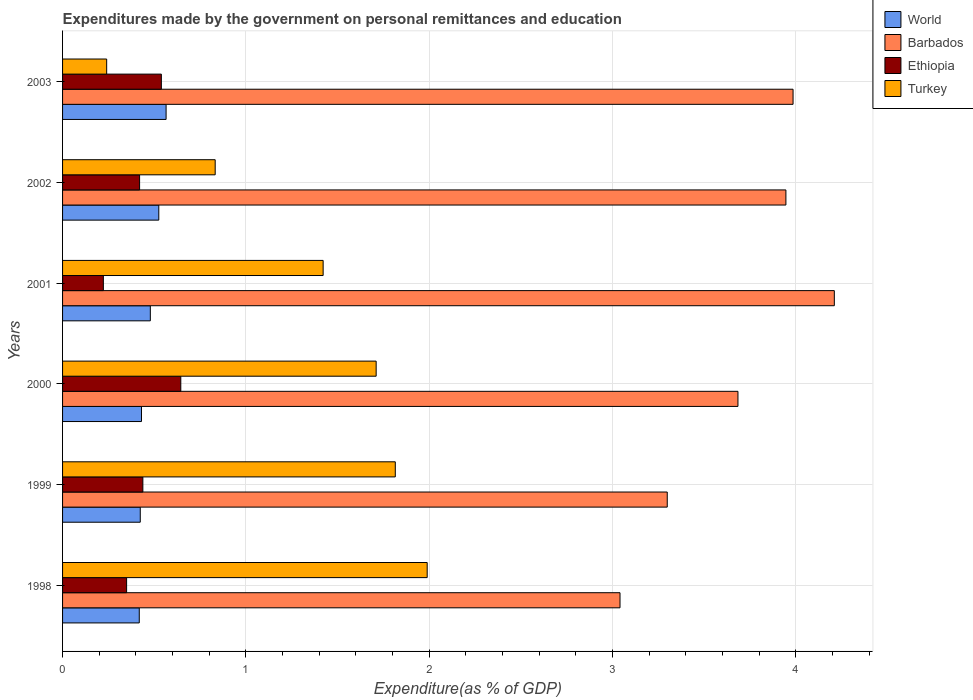How many groups of bars are there?
Your answer should be compact. 6. Are the number of bars per tick equal to the number of legend labels?
Make the answer very short. Yes. How many bars are there on the 4th tick from the top?
Your answer should be compact. 4. How many bars are there on the 6th tick from the bottom?
Your answer should be very brief. 4. What is the label of the 6th group of bars from the top?
Provide a succinct answer. 1998. In how many cases, is the number of bars for a given year not equal to the number of legend labels?
Ensure brevity in your answer.  0. What is the expenditures made by the government on personal remittances and education in World in 2003?
Make the answer very short. 0.56. Across all years, what is the maximum expenditures made by the government on personal remittances and education in Ethiopia?
Give a very brief answer. 0.64. Across all years, what is the minimum expenditures made by the government on personal remittances and education in Turkey?
Provide a succinct answer. 0.24. In which year was the expenditures made by the government on personal remittances and education in World maximum?
Keep it short and to the point. 2003. What is the total expenditures made by the government on personal remittances and education in Turkey in the graph?
Your answer should be very brief. 8.01. What is the difference between the expenditures made by the government on personal remittances and education in Turkey in 1998 and that in 2001?
Ensure brevity in your answer.  0.57. What is the difference between the expenditures made by the government on personal remittances and education in Ethiopia in 1999 and the expenditures made by the government on personal remittances and education in Turkey in 2002?
Provide a short and direct response. -0.39. What is the average expenditures made by the government on personal remittances and education in Ethiopia per year?
Provide a succinct answer. 0.44. In the year 1998, what is the difference between the expenditures made by the government on personal remittances and education in Ethiopia and expenditures made by the government on personal remittances and education in World?
Provide a short and direct response. -0.07. In how many years, is the expenditures made by the government on personal remittances and education in Turkey greater than 1.4 %?
Your answer should be compact. 4. What is the ratio of the expenditures made by the government on personal remittances and education in World in 1998 to that in 1999?
Provide a succinct answer. 0.99. Is the expenditures made by the government on personal remittances and education in Turkey in 2000 less than that in 2001?
Give a very brief answer. No. Is the difference between the expenditures made by the government on personal remittances and education in Ethiopia in 1999 and 2001 greater than the difference between the expenditures made by the government on personal remittances and education in World in 1999 and 2001?
Offer a very short reply. Yes. What is the difference between the highest and the second highest expenditures made by the government on personal remittances and education in Ethiopia?
Give a very brief answer. 0.11. What is the difference between the highest and the lowest expenditures made by the government on personal remittances and education in Ethiopia?
Offer a terse response. 0.42. What does the 2nd bar from the top in 1999 represents?
Give a very brief answer. Ethiopia. What does the 1st bar from the bottom in 2003 represents?
Your response must be concise. World. How many bars are there?
Make the answer very short. 24. How many years are there in the graph?
Provide a short and direct response. 6. Are the values on the major ticks of X-axis written in scientific E-notation?
Provide a succinct answer. No. Does the graph contain any zero values?
Provide a succinct answer. No. Where does the legend appear in the graph?
Make the answer very short. Top right. How many legend labels are there?
Ensure brevity in your answer.  4. What is the title of the graph?
Make the answer very short. Expenditures made by the government on personal remittances and education. What is the label or title of the X-axis?
Ensure brevity in your answer.  Expenditure(as % of GDP). What is the Expenditure(as % of GDP) in World in 1998?
Make the answer very short. 0.42. What is the Expenditure(as % of GDP) in Barbados in 1998?
Your answer should be very brief. 3.04. What is the Expenditure(as % of GDP) in Ethiopia in 1998?
Your answer should be very brief. 0.35. What is the Expenditure(as % of GDP) of Turkey in 1998?
Keep it short and to the point. 1.99. What is the Expenditure(as % of GDP) in World in 1999?
Offer a very short reply. 0.42. What is the Expenditure(as % of GDP) in Barbados in 1999?
Make the answer very short. 3.3. What is the Expenditure(as % of GDP) in Ethiopia in 1999?
Your answer should be compact. 0.44. What is the Expenditure(as % of GDP) of Turkey in 1999?
Ensure brevity in your answer.  1.82. What is the Expenditure(as % of GDP) in World in 2000?
Provide a short and direct response. 0.43. What is the Expenditure(as % of GDP) of Barbados in 2000?
Offer a terse response. 3.68. What is the Expenditure(as % of GDP) in Ethiopia in 2000?
Your response must be concise. 0.64. What is the Expenditure(as % of GDP) in Turkey in 2000?
Provide a succinct answer. 1.71. What is the Expenditure(as % of GDP) of World in 2001?
Your answer should be compact. 0.48. What is the Expenditure(as % of GDP) in Barbados in 2001?
Offer a very short reply. 4.21. What is the Expenditure(as % of GDP) of Ethiopia in 2001?
Your response must be concise. 0.22. What is the Expenditure(as % of GDP) of Turkey in 2001?
Your response must be concise. 1.42. What is the Expenditure(as % of GDP) in World in 2002?
Ensure brevity in your answer.  0.52. What is the Expenditure(as % of GDP) of Barbados in 2002?
Offer a terse response. 3.95. What is the Expenditure(as % of GDP) in Ethiopia in 2002?
Provide a succinct answer. 0.42. What is the Expenditure(as % of GDP) in Turkey in 2002?
Keep it short and to the point. 0.83. What is the Expenditure(as % of GDP) in World in 2003?
Offer a terse response. 0.56. What is the Expenditure(as % of GDP) of Barbados in 2003?
Give a very brief answer. 3.98. What is the Expenditure(as % of GDP) of Ethiopia in 2003?
Your answer should be compact. 0.54. What is the Expenditure(as % of GDP) of Turkey in 2003?
Your answer should be compact. 0.24. Across all years, what is the maximum Expenditure(as % of GDP) in World?
Offer a very short reply. 0.56. Across all years, what is the maximum Expenditure(as % of GDP) of Barbados?
Provide a succinct answer. 4.21. Across all years, what is the maximum Expenditure(as % of GDP) of Ethiopia?
Offer a terse response. 0.64. Across all years, what is the maximum Expenditure(as % of GDP) in Turkey?
Make the answer very short. 1.99. Across all years, what is the minimum Expenditure(as % of GDP) in World?
Provide a short and direct response. 0.42. Across all years, what is the minimum Expenditure(as % of GDP) of Barbados?
Offer a terse response. 3.04. Across all years, what is the minimum Expenditure(as % of GDP) of Ethiopia?
Your response must be concise. 0.22. Across all years, what is the minimum Expenditure(as % of GDP) of Turkey?
Offer a very short reply. 0.24. What is the total Expenditure(as % of GDP) in World in the graph?
Your answer should be compact. 2.84. What is the total Expenditure(as % of GDP) in Barbados in the graph?
Offer a terse response. 22.16. What is the total Expenditure(as % of GDP) of Ethiopia in the graph?
Make the answer very short. 2.61. What is the total Expenditure(as % of GDP) in Turkey in the graph?
Provide a short and direct response. 8.01. What is the difference between the Expenditure(as % of GDP) in World in 1998 and that in 1999?
Keep it short and to the point. -0.01. What is the difference between the Expenditure(as % of GDP) in Barbados in 1998 and that in 1999?
Provide a short and direct response. -0.26. What is the difference between the Expenditure(as % of GDP) of Ethiopia in 1998 and that in 1999?
Make the answer very short. -0.09. What is the difference between the Expenditure(as % of GDP) in Turkey in 1998 and that in 1999?
Keep it short and to the point. 0.17. What is the difference between the Expenditure(as % of GDP) of World in 1998 and that in 2000?
Provide a succinct answer. -0.01. What is the difference between the Expenditure(as % of GDP) in Barbados in 1998 and that in 2000?
Offer a very short reply. -0.64. What is the difference between the Expenditure(as % of GDP) in Ethiopia in 1998 and that in 2000?
Ensure brevity in your answer.  -0.3. What is the difference between the Expenditure(as % of GDP) in Turkey in 1998 and that in 2000?
Offer a very short reply. 0.28. What is the difference between the Expenditure(as % of GDP) in World in 1998 and that in 2001?
Make the answer very short. -0.06. What is the difference between the Expenditure(as % of GDP) in Barbados in 1998 and that in 2001?
Provide a short and direct response. -1.17. What is the difference between the Expenditure(as % of GDP) of Ethiopia in 1998 and that in 2001?
Ensure brevity in your answer.  0.13. What is the difference between the Expenditure(as % of GDP) of Turkey in 1998 and that in 2001?
Provide a succinct answer. 0.57. What is the difference between the Expenditure(as % of GDP) of World in 1998 and that in 2002?
Provide a succinct answer. -0.11. What is the difference between the Expenditure(as % of GDP) of Barbados in 1998 and that in 2002?
Offer a very short reply. -0.91. What is the difference between the Expenditure(as % of GDP) in Ethiopia in 1998 and that in 2002?
Offer a terse response. -0.07. What is the difference between the Expenditure(as % of GDP) of Turkey in 1998 and that in 2002?
Your answer should be compact. 1.16. What is the difference between the Expenditure(as % of GDP) in World in 1998 and that in 2003?
Provide a succinct answer. -0.15. What is the difference between the Expenditure(as % of GDP) of Barbados in 1998 and that in 2003?
Provide a short and direct response. -0.94. What is the difference between the Expenditure(as % of GDP) in Ethiopia in 1998 and that in 2003?
Ensure brevity in your answer.  -0.19. What is the difference between the Expenditure(as % of GDP) of Turkey in 1998 and that in 2003?
Make the answer very short. 1.75. What is the difference between the Expenditure(as % of GDP) of World in 1999 and that in 2000?
Keep it short and to the point. -0.01. What is the difference between the Expenditure(as % of GDP) in Barbados in 1999 and that in 2000?
Your response must be concise. -0.39. What is the difference between the Expenditure(as % of GDP) in Ethiopia in 1999 and that in 2000?
Your answer should be compact. -0.21. What is the difference between the Expenditure(as % of GDP) of Turkey in 1999 and that in 2000?
Your answer should be very brief. 0.1. What is the difference between the Expenditure(as % of GDP) in World in 1999 and that in 2001?
Your answer should be very brief. -0.05. What is the difference between the Expenditure(as % of GDP) in Barbados in 1999 and that in 2001?
Keep it short and to the point. -0.91. What is the difference between the Expenditure(as % of GDP) of Ethiopia in 1999 and that in 2001?
Make the answer very short. 0.22. What is the difference between the Expenditure(as % of GDP) in Turkey in 1999 and that in 2001?
Your response must be concise. 0.39. What is the difference between the Expenditure(as % of GDP) of World in 1999 and that in 2002?
Provide a succinct answer. -0.1. What is the difference between the Expenditure(as % of GDP) of Barbados in 1999 and that in 2002?
Your answer should be compact. -0.65. What is the difference between the Expenditure(as % of GDP) of Ethiopia in 1999 and that in 2002?
Give a very brief answer. 0.02. What is the difference between the Expenditure(as % of GDP) of Turkey in 1999 and that in 2002?
Offer a very short reply. 0.98. What is the difference between the Expenditure(as % of GDP) in World in 1999 and that in 2003?
Provide a succinct answer. -0.14. What is the difference between the Expenditure(as % of GDP) in Barbados in 1999 and that in 2003?
Provide a succinct answer. -0.69. What is the difference between the Expenditure(as % of GDP) of Ethiopia in 1999 and that in 2003?
Give a very brief answer. -0.1. What is the difference between the Expenditure(as % of GDP) of Turkey in 1999 and that in 2003?
Your answer should be very brief. 1.57. What is the difference between the Expenditure(as % of GDP) of World in 2000 and that in 2001?
Your response must be concise. -0.05. What is the difference between the Expenditure(as % of GDP) of Barbados in 2000 and that in 2001?
Give a very brief answer. -0.53. What is the difference between the Expenditure(as % of GDP) in Ethiopia in 2000 and that in 2001?
Offer a terse response. 0.42. What is the difference between the Expenditure(as % of GDP) in Turkey in 2000 and that in 2001?
Your response must be concise. 0.29. What is the difference between the Expenditure(as % of GDP) in World in 2000 and that in 2002?
Offer a terse response. -0.09. What is the difference between the Expenditure(as % of GDP) in Barbados in 2000 and that in 2002?
Provide a succinct answer. -0.26. What is the difference between the Expenditure(as % of GDP) in Ethiopia in 2000 and that in 2002?
Your answer should be very brief. 0.22. What is the difference between the Expenditure(as % of GDP) of Turkey in 2000 and that in 2002?
Your answer should be very brief. 0.88. What is the difference between the Expenditure(as % of GDP) of World in 2000 and that in 2003?
Your answer should be very brief. -0.13. What is the difference between the Expenditure(as % of GDP) of Barbados in 2000 and that in 2003?
Keep it short and to the point. -0.3. What is the difference between the Expenditure(as % of GDP) in Ethiopia in 2000 and that in 2003?
Your response must be concise. 0.11. What is the difference between the Expenditure(as % of GDP) in Turkey in 2000 and that in 2003?
Offer a terse response. 1.47. What is the difference between the Expenditure(as % of GDP) of World in 2001 and that in 2002?
Your answer should be compact. -0.05. What is the difference between the Expenditure(as % of GDP) of Barbados in 2001 and that in 2002?
Offer a very short reply. 0.26. What is the difference between the Expenditure(as % of GDP) in Ethiopia in 2001 and that in 2002?
Give a very brief answer. -0.2. What is the difference between the Expenditure(as % of GDP) in Turkey in 2001 and that in 2002?
Ensure brevity in your answer.  0.59. What is the difference between the Expenditure(as % of GDP) in World in 2001 and that in 2003?
Make the answer very short. -0.09. What is the difference between the Expenditure(as % of GDP) of Barbados in 2001 and that in 2003?
Your answer should be very brief. 0.23. What is the difference between the Expenditure(as % of GDP) in Ethiopia in 2001 and that in 2003?
Offer a very short reply. -0.32. What is the difference between the Expenditure(as % of GDP) of Turkey in 2001 and that in 2003?
Ensure brevity in your answer.  1.18. What is the difference between the Expenditure(as % of GDP) of World in 2002 and that in 2003?
Provide a succinct answer. -0.04. What is the difference between the Expenditure(as % of GDP) of Barbados in 2002 and that in 2003?
Provide a short and direct response. -0.04. What is the difference between the Expenditure(as % of GDP) in Ethiopia in 2002 and that in 2003?
Ensure brevity in your answer.  -0.12. What is the difference between the Expenditure(as % of GDP) in Turkey in 2002 and that in 2003?
Your response must be concise. 0.59. What is the difference between the Expenditure(as % of GDP) in World in 1998 and the Expenditure(as % of GDP) in Barbados in 1999?
Provide a succinct answer. -2.88. What is the difference between the Expenditure(as % of GDP) of World in 1998 and the Expenditure(as % of GDP) of Ethiopia in 1999?
Keep it short and to the point. -0.02. What is the difference between the Expenditure(as % of GDP) in World in 1998 and the Expenditure(as % of GDP) in Turkey in 1999?
Provide a short and direct response. -1.4. What is the difference between the Expenditure(as % of GDP) of Barbados in 1998 and the Expenditure(as % of GDP) of Ethiopia in 1999?
Provide a succinct answer. 2.6. What is the difference between the Expenditure(as % of GDP) of Barbados in 1998 and the Expenditure(as % of GDP) of Turkey in 1999?
Offer a terse response. 1.23. What is the difference between the Expenditure(as % of GDP) of Ethiopia in 1998 and the Expenditure(as % of GDP) of Turkey in 1999?
Keep it short and to the point. -1.47. What is the difference between the Expenditure(as % of GDP) in World in 1998 and the Expenditure(as % of GDP) in Barbados in 2000?
Your answer should be very brief. -3.27. What is the difference between the Expenditure(as % of GDP) in World in 1998 and the Expenditure(as % of GDP) in Ethiopia in 2000?
Your response must be concise. -0.23. What is the difference between the Expenditure(as % of GDP) in World in 1998 and the Expenditure(as % of GDP) in Turkey in 2000?
Make the answer very short. -1.29. What is the difference between the Expenditure(as % of GDP) of Barbados in 1998 and the Expenditure(as % of GDP) of Ethiopia in 2000?
Make the answer very short. 2.4. What is the difference between the Expenditure(as % of GDP) in Barbados in 1998 and the Expenditure(as % of GDP) in Turkey in 2000?
Ensure brevity in your answer.  1.33. What is the difference between the Expenditure(as % of GDP) of Ethiopia in 1998 and the Expenditure(as % of GDP) of Turkey in 2000?
Offer a terse response. -1.36. What is the difference between the Expenditure(as % of GDP) of World in 1998 and the Expenditure(as % of GDP) of Barbados in 2001?
Keep it short and to the point. -3.79. What is the difference between the Expenditure(as % of GDP) in World in 1998 and the Expenditure(as % of GDP) in Ethiopia in 2001?
Keep it short and to the point. 0.2. What is the difference between the Expenditure(as % of GDP) of World in 1998 and the Expenditure(as % of GDP) of Turkey in 2001?
Give a very brief answer. -1. What is the difference between the Expenditure(as % of GDP) in Barbados in 1998 and the Expenditure(as % of GDP) in Ethiopia in 2001?
Ensure brevity in your answer.  2.82. What is the difference between the Expenditure(as % of GDP) in Barbados in 1998 and the Expenditure(as % of GDP) in Turkey in 2001?
Your answer should be very brief. 1.62. What is the difference between the Expenditure(as % of GDP) in Ethiopia in 1998 and the Expenditure(as % of GDP) in Turkey in 2001?
Make the answer very short. -1.07. What is the difference between the Expenditure(as % of GDP) in World in 1998 and the Expenditure(as % of GDP) in Barbados in 2002?
Keep it short and to the point. -3.53. What is the difference between the Expenditure(as % of GDP) of World in 1998 and the Expenditure(as % of GDP) of Ethiopia in 2002?
Offer a terse response. -0. What is the difference between the Expenditure(as % of GDP) of World in 1998 and the Expenditure(as % of GDP) of Turkey in 2002?
Your response must be concise. -0.41. What is the difference between the Expenditure(as % of GDP) of Barbados in 1998 and the Expenditure(as % of GDP) of Ethiopia in 2002?
Your answer should be compact. 2.62. What is the difference between the Expenditure(as % of GDP) in Barbados in 1998 and the Expenditure(as % of GDP) in Turkey in 2002?
Give a very brief answer. 2.21. What is the difference between the Expenditure(as % of GDP) of Ethiopia in 1998 and the Expenditure(as % of GDP) of Turkey in 2002?
Offer a very short reply. -0.48. What is the difference between the Expenditure(as % of GDP) in World in 1998 and the Expenditure(as % of GDP) in Barbados in 2003?
Provide a short and direct response. -3.57. What is the difference between the Expenditure(as % of GDP) in World in 1998 and the Expenditure(as % of GDP) in Ethiopia in 2003?
Your response must be concise. -0.12. What is the difference between the Expenditure(as % of GDP) of World in 1998 and the Expenditure(as % of GDP) of Turkey in 2003?
Your answer should be compact. 0.18. What is the difference between the Expenditure(as % of GDP) in Barbados in 1998 and the Expenditure(as % of GDP) in Ethiopia in 2003?
Your answer should be compact. 2.5. What is the difference between the Expenditure(as % of GDP) in Barbados in 1998 and the Expenditure(as % of GDP) in Turkey in 2003?
Your answer should be compact. 2.8. What is the difference between the Expenditure(as % of GDP) of Ethiopia in 1998 and the Expenditure(as % of GDP) of Turkey in 2003?
Keep it short and to the point. 0.11. What is the difference between the Expenditure(as % of GDP) in World in 1999 and the Expenditure(as % of GDP) in Barbados in 2000?
Make the answer very short. -3.26. What is the difference between the Expenditure(as % of GDP) in World in 1999 and the Expenditure(as % of GDP) in Ethiopia in 2000?
Provide a short and direct response. -0.22. What is the difference between the Expenditure(as % of GDP) of World in 1999 and the Expenditure(as % of GDP) of Turkey in 2000?
Ensure brevity in your answer.  -1.29. What is the difference between the Expenditure(as % of GDP) of Barbados in 1999 and the Expenditure(as % of GDP) of Ethiopia in 2000?
Provide a short and direct response. 2.65. What is the difference between the Expenditure(as % of GDP) in Barbados in 1999 and the Expenditure(as % of GDP) in Turkey in 2000?
Ensure brevity in your answer.  1.59. What is the difference between the Expenditure(as % of GDP) of Ethiopia in 1999 and the Expenditure(as % of GDP) of Turkey in 2000?
Your response must be concise. -1.27. What is the difference between the Expenditure(as % of GDP) of World in 1999 and the Expenditure(as % of GDP) of Barbados in 2001?
Give a very brief answer. -3.79. What is the difference between the Expenditure(as % of GDP) in World in 1999 and the Expenditure(as % of GDP) in Ethiopia in 2001?
Offer a terse response. 0.2. What is the difference between the Expenditure(as % of GDP) in World in 1999 and the Expenditure(as % of GDP) in Turkey in 2001?
Provide a short and direct response. -1. What is the difference between the Expenditure(as % of GDP) of Barbados in 1999 and the Expenditure(as % of GDP) of Ethiopia in 2001?
Provide a succinct answer. 3.08. What is the difference between the Expenditure(as % of GDP) of Barbados in 1999 and the Expenditure(as % of GDP) of Turkey in 2001?
Ensure brevity in your answer.  1.88. What is the difference between the Expenditure(as % of GDP) of Ethiopia in 1999 and the Expenditure(as % of GDP) of Turkey in 2001?
Ensure brevity in your answer.  -0.98. What is the difference between the Expenditure(as % of GDP) in World in 1999 and the Expenditure(as % of GDP) in Barbados in 2002?
Offer a terse response. -3.52. What is the difference between the Expenditure(as % of GDP) in World in 1999 and the Expenditure(as % of GDP) in Ethiopia in 2002?
Keep it short and to the point. 0. What is the difference between the Expenditure(as % of GDP) in World in 1999 and the Expenditure(as % of GDP) in Turkey in 2002?
Provide a succinct answer. -0.41. What is the difference between the Expenditure(as % of GDP) in Barbados in 1999 and the Expenditure(as % of GDP) in Ethiopia in 2002?
Offer a very short reply. 2.88. What is the difference between the Expenditure(as % of GDP) of Barbados in 1999 and the Expenditure(as % of GDP) of Turkey in 2002?
Your response must be concise. 2.47. What is the difference between the Expenditure(as % of GDP) in Ethiopia in 1999 and the Expenditure(as % of GDP) in Turkey in 2002?
Offer a very short reply. -0.39. What is the difference between the Expenditure(as % of GDP) of World in 1999 and the Expenditure(as % of GDP) of Barbados in 2003?
Make the answer very short. -3.56. What is the difference between the Expenditure(as % of GDP) of World in 1999 and the Expenditure(as % of GDP) of Ethiopia in 2003?
Keep it short and to the point. -0.12. What is the difference between the Expenditure(as % of GDP) of World in 1999 and the Expenditure(as % of GDP) of Turkey in 2003?
Your answer should be compact. 0.18. What is the difference between the Expenditure(as % of GDP) of Barbados in 1999 and the Expenditure(as % of GDP) of Ethiopia in 2003?
Keep it short and to the point. 2.76. What is the difference between the Expenditure(as % of GDP) in Barbados in 1999 and the Expenditure(as % of GDP) in Turkey in 2003?
Your answer should be very brief. 3.06. What is the difference between the Expenditure(as % of GDP) in Ethiopia in 1999 and the Expenditure(as % of GDP) in Turkey in 2003?
Ensure brevity in your answer.  0.2. What is the difference between the Expenditure(as % of GDP) in World in 2000 and the Expenditure(as % of GDP) in Barbados in 2001?
Your answer should be very brief. -3.78. What is the difference between the Expenditure(as % of GDP) of World in 2000 and the Expenditure(as % of GDP) of Ethiopia in 2001?
Your answer should be very brief. 0.21. What is the difference between the Expenditure(as % of GDP) of World in 2000 and the Expenditure(as % of GDP) of Turkey in 2001?
Offer a terse response. -0.99. What is the difference between the Expenditure(as % of GDP) in Barbados in 2000 and the Expenditure(as % of GDP) in Ethiopia in 2001?
Give a very brief answer. 3.46. What is the difference between the Expenditure(as % of GDP) of Barbados in 2000 and the Expenditure(as % of GDP) of Turkey in 2001?
Offer a terse response. 2.26. What is the difference between the Expenditure(as % of GDP) of Ethiopia in 2000 and the Expenditure(as % of GDP) of Turkey in 2001?
Make the answer very short. -0.78. What is the difference between the Expenditure(as % of GDP) in World in 2000 and the Expenditure(as % of GDP) in Barbados in 2002?
Give a very brief answer. -3.52. What is the difference between the Expenditure(as % of GDP) in World in 2000 and the Expenditure(as % of GDP) in Ethiopia in 2002?
Offer a very short reply. 0.01. What is the difference between the Expenditure(as % of GDP) of World in 2000 and the Expenditure(as % of GDP) of Turkey in 2002?
Your answer should be very brief. -0.4. What is the difference between the Expenditure(as % of GDP) of Barbados in 2000 and the Expenditure(as % of GDP) of Ethiopia in 2002?
Ensure brevity in your answer.  3.26. What is the difference between the Expenditure(as % of GDP) in Barbados in 2000 and the Expenditure(as % of GDP) in Turkey in 2002?
Your response must be concise. 2.85. What is the difference between the Expenditure(as % of GDP) in Ethiopia in 2000 and the Expenditure(as % of GDP) in Turkey in 2002?
Provide a short and direct response. -0.19. What is the difference between the Expenditure(as % of GDP) in World in 2000 and the Expenditure(as % of GDP) in Barbados in 2003?
Make the answer very short. -3.55. What is the difference between the Expenditure(as % of GDP) in World in 2000 and the Expenditure(as % of GDP) in Ethiopia in 2003?
Offer a very short reply. -0.11. What is the difference between the Expenditure(as % of GDP) in World in 2000 and the Expenditure(as % of GDP) in Turkey in 2003?
Provide a short and direct response. 0.19. What is the difference between the Expenditure(as % of GDP) in Barbados in 2000 and the Expenditure(as % of GDP) in Ethiopia in 2003?
Your answer should be compact. 3.15. What is the difference between the Expenditure(as % of GDP) in Barbados in 2000 and the Expenditure(as % of GDP) in Turkey in 2003?
Offer a terse response. 3.44. What is the difference between the Expenditure(as % of GDP) of Ethiopia in 2000 and the Expenditure(as % of GDP) of Turkey in 2003?
Provide a short and direct response. 0.4. What is the difference between the Expenditure(as % of GDP) of World in 2001 and the Expenditure(as % of GDP) of Barbados in 2002?
Make the answer very short. -3.47. What is the difference between the Expenditure(as % of GDP) in World in 2001 and the Expenditure(as % of GDP) in Ethiopia in 2002?
Your answer should be compact. 0.06. What is the difference between the Expenditure(as % of GDP) in World in 2001 and the Expenditure(as % of GDP) in Turkey in 2002?
Provide a short and direct response. -0.35. What is the difference between the Expenditure(as % of GDP) of Barbados in 2001 and the Expenditure(as % of GDP) of Ethiopia in 2002?
Offer a terse response. 3.79. What is the difference between the Expenditure(as % of GDP) of Barbados in 2001 and the Expenditure(as % of GDP) of Turkey in 2002?
Offer a terse response. 3.38. What is the difference between the Expenditure(as % of GDP) in Ethiopia in 2001 and the Expenditure(as % of GDP) in Turkey in 2002?
Ensure brevity in your answer.  -0.61. What is the difference between the Expenditure(as % of GDP) in World in 2001 and the Expenditure(as % of GDP) in Barbados in 2003?
Keep it short and to the point. -3.51. What is the difference between the Expenditure(as % of GDP) of World in 2001 and the Expenditure(as % of GDP) of Ethiopia in 2003?
Offer a terse response. -0.06. What is the difference between the Expenditure(as % of GDP) in World in 2001 and the Expenditure(as % of GDP) in Turkey in 2003?
Provide a short and direct response. 0.24. What is the difference between the Expenditure(as % of GDP) in Barbados in 2001 and the Expenditure(as % of GDP) in Ethiopia in 2003?
Ensure brevity in your answer.  3.67. What is the difference between the Expenditure(as % of GDP) of Barbados in 2001 and the Expenditure(as % of GDP) of Turkey in 2003?
Provide a succinct answer. 3.97. What is the difference between the Expenditure(as % of GDP) in Ethiopia in 2001 and the Expenditure(as % of GDP) in Turkey in 2003?
Give a very brief answer. -0.02. What is the difference between the Expenditure(as % of GDP) in World in 2002 and the Expenditure(as % of GDP) in Barbados in 2003?
Your response must be concise. -3.46. What is the difference between the Expenditure(as % of GDP) in World in 2002 and the Expenditure(as % of GDP) in Ethiopia in 2003?
Your response must be concise. -0.01. What is the difference between the Expenditure(as % of GDP) of World in 2002 and the Expenditure(as % of GDP) of Turkey in 2003?
Offer a terse response. 0.28. What is the difference between the Expenditure(as % of GDP) in Barbados in 2002 and the Expenditure(as % of GDP) in Ethiopia in 2003?
Offer a very short reply. 3.41. What is the difference between the Expenditure(as % of GDP) in Barbados in 2002 and the Expenditure(as % of GDP) in Turkey in 2003?
Your answer should be very brief. 3.71. What is the difference between the Expenditure(as % of GDP) of Ethiopia in 2002 and the Expenditure(as % of GDP) of Turkey in 2003?
Make the answer very short. 0.18. What is the average Expenditure(as % of GDP) of World per year?
Your answer should be compact. 0.47. What is the average Expenditure(as % of GDP) in Barbados per year?
Your answer should be compact. 3.69. What is the average Expenditure(as % of GDP) of Ethiopia per year?
Make the answer very short. 0.44. What is the average Expenditure(as % of GDP) of Turkey per year?
Your response must be concise. 1.33. In the year 1998, what is the difference between the Expenditure(as % of GDP) of World and Expenditure(as % of GDP) of Barbados?
Your response must be concise. -2.62. In the year 1998, what is the difference between the Expenditure(as % of GDP) in World and Expenditure(as % of GDP) in Ethiopia?
Make the answer very short. 0.07. In the year 1998, what is the difference between the Expenditure(as % of GDP) in World and Expenditure(as % of GDP) in Turkey?
Provide a short and direct response. -1.57. In the year 1998, what is the difference between the Expenditure(as % of GDP) in Barbados and Expenditure(as % of GDP) in Ethiopia?
Offer a terse response. 2.69. In the year 1998, what is the difference between the Expenditure(as % of GDP) in Barbados and Expenditure(as % of GDP) in Turkey?
Offer a very short reply. 1.05. In the year 1998, what is the difference between the Expenditure(as % of GDP) in Ethiopia and Expenditure(as % of GDP) in Turkey?
Offer a terse response. -1.64. In the year 1999, what is the difference between the Expenditure(as % of GDP) of World and Expenditure(as % of GDP) of Barbados?
Provide a succinct answer. -2.87. In the year 1999, what is the difference between the Expenditure(as % of GDP) in World and Expenditure(as % of GDP) in Ethiopia?
Your answer should be very brief. -0.01. In the year 1999, what is the difference between the Expenditure(as % of GDP) in World and Expenditure(as % of GDP) in Turkey?
Give a very brief answer. -1.39. In the year 1999, what is the difference between the Expenditure(as % of GDP) in Barbados and Expenditure(as % of GDP) in Ethiopia?
Make the answer very short. 2.86. In the year 1999, what is the difference between the Expenditure(as % of GDP) in Barbados and Expenditure(as % of GDP) in Turkey?
Make the answer very short. 1.48. In the year 1999, what is the difference between the Expenditure(as % of GDP) of Ethiopia and Expenditure(as % of GDP) of Turkey?
Ensure brevity in your answer.  -1.38. In the year 2000, what is the difference between the Expenditure(as % of GDP) of World and Expenditure(as % of GDP) of Barbados?
Provide a succinct answer. -3.25. In the year 2000, what is the difference between the Expenditure(as % of GDP) in World and Expenditure(as % of GDP) in Ethiopia?
Offer a terse response. -0.21. In the year 2000, what is the difference between the Expenditure(as % of GDP) in World and Expenditure(as % of GDP) in Turkey?
Your answer should be compact. -1.28. In the year 2000, what is the difference between the Expenditure(as % of GDP) in Barbados and Expenditure(as % of GDP) in Ethiopia?
Offer a terse response. 3.04. In the year 2000, what is the difference between the Expenditure(as % of GDP) in Barbados and Expenditure(as % of GDP) in Turkey?
Provide a succinct answer. 1.97. In the year 2000, what is the difference between the Expenditure(as % of GDP) of Ethiopia and Expenditure(as % of GDP) of Turkey?
Your answer should be compact. -1.07. In the year 2001, what is the difference between the Expenditure(as % of GDP) of World and Expenditure(as % of GDP) of Barbados?
Provide a short and direct response. -3.73. In the year 2001, what is the difference between the Expenditure(as % of GDP) of World and Expenditure(as % of GDP) of Ethiopia?
Provide a succinct answer. 0.26. In the year 2001, what is the difference between the Expenditure(as % of GDP) in World and Expenditure(as % of GDP) in Turkey?
Keep it short and to the point. -0.94. In the year 2001, what is the difference between the Expenditure(as % of GDP) in Barbados and Expenditure(as % of GDP) in Ethiopia?
Offer a terse response. 3.99. In the year 2001, what is the difference between the Expenditure(as % of GDP) in Barbados and Expenditure(as % of GDP) in Turkey?
Offer a very short reply. 2.79. In the year 2001, what is the difference between the Expenditure(as % of GDP) of Ethiopia and Expenditure(as % of GDP) of Turkey?
Provide a short and direct response. -1.2. In the year 2002, what is the difference between the Expenditure(as % of GDP) in World and Expenditure(as % of GDP) in Barbados?
Make the answer very short. -3.42. In the year 2002, what is the difference between the Expenditure(as % of GDP) in World and Expenditure(as % of GDP) in Ethiopia?
Your answer should be compact. 0.1. In the year 2002, what is the difference between the Expenditure(as % of GDP) in World and Expenditure(as % of GDP) in Turkey?
Your response must be concise. -0.31. In the year 2002, what is the difference between the Expenditure(as % of GDP) of Barbados and Expenditure(as % of GDP) of Ethiopia?
Provide a succinct answer. 3.53. In the year 2002, what is the difference between the Expenditure(as % of GDP) in Barbados and Expenditure(as % of GDP) in Turkey?
Provide a succinct answer. 3.11. In the year 2002, what is the difference between the Expenditure(as % of GDP) in Ethiopia and Expenditure(as % of GDP) in Turkey?
Your response must be concise. -0.41. In the year 2003, what is the difference between the Expenditure(as % of GDP) in World and Expenditure(as % of GDP) in Barbados?
Provide a short and direct response. -3.42. In the year 2003, what is the difference between the Expenditure(as % of GDP) in World and Expenditure(as % of GDP) in Ethiopia?
Offer a terse response. 0.03. In the year 2003, what is the difference between the Expenditure(as % of GDP) of World and Expenditure(as % of GDP) of Turkey?
Your response must be concise. 0.32. In the year 2003, what is the difference between the Expenditure(as % of GDP) in Barbados and Expenditure(as % of GDP) in Ethiopia?
Provide a succinct answer. 3.45. In the year 2003, what is the difference between the Expenditure(as % of GDP) of Barbados and Expenditure(as % of GDP) of Turkey?
Provide a succinct answer. 3.74. In the year 2003, what is the difference between the Expenditure(as % of GDP) of Ethiopia and Expenditure(as % of GDP) of Turkey?
Offer a terse response. 0.3. What is the ratio of the Expenditure(as % of GDP) of World in 1998 to that in 1999?
Keep it short and to the point. 0.99. What is the ratio of the Expenditure(as % of GDP) in Barbados in 1998 to that in 1999?
Your answer should be compact. 0.92. What is the ratio of the Expenditure(as % of GDP) in Ethiopia in 1998 to that in 1999?
Ensure brevity in your answer.  0.8. What is the ratio of the Expenditure(as % of GDP) of Turkey in 1998 to that in 1999?
Your answer should be very brief. 1.1. What is the ratio of the Expenditure(as % of GDP) in World in 1998 to that in 2000?
Offer a terse response. 0.97. What is the ratio of the Expenditure(as % of GDP) in Barbados in 1998 to that in 2000?
Provide a short and direct response. 0.83. What is the ratio of the Expenditure(as % of GDP) of Ethiopia in 1998 to that in 2000?
Provide a succinct answer. 0.54. What is the ratio of the Expenditure(as % of GDP) of Turkey in 1998 to that in 2000?
Provide a succinct answer. 1.16. What is the ratio of the Expenditure(as % of GDP) of World in 1998 to that in 2001?
Keep it short and to the point. 0.87. What is the ratio of the Expenditure(as % of GDP) in Barbados in 1998 to that in 2001?
Your response must be concise. 0.72. What is the ratio of the Expenditure(as % of GDP) in Ethiopia in 1998 to that in 2001?
Make the answer very short. 1.57. What is the ratio of the Expenditure(as % of GDP) of Turkey in 1998 to that in 2001?
Make the answer very short. 1.4. What is the ratio of the Expenditure(as % of GDP) in World in 1998 to that in 2002?
Your answer should be very brief. 0.8. What is the ratio of the Expenditure(as % of GDP) of Barbados in 1998 to that in 2002?
Your answer should be compact. 0.77. What is the ratio of the Expenditure(as % of GDP) in Ethiopia in 1998 to that in 2002?
Provide a short and direct response. 0.83. What is the ratio of the Expenditure(as % of GDP) in Turkey in 1998 to that in 2002?
Offer a terse response. 2.39. What is the ratio of the Expenditure(as % of GDP) of World in 1998 to that in 2003?
Provide a succinct answer. 0.74. What is the ratio of the Expenditure(as % of GDP) of Barbados in 1998 to that in 2003?
Keep it short and to the point. 0.76. What is the ratio of the Expenditure(as % of GDP) in Ethiopia in 1998 to that in 2003?
Ensure brevity in your answer.  0.65. What is the ratio of the Expenditure(as % of GDP) in Turkey in 1998 to that in 2003?
Make the answer very short. 8.27. What is the ratio of the Expenditure(as % of GDP) in World in 1999 to that in 2000?
Give a very brief answer. 0.98. What is the ratio of the Expenditure(as % of GDP) in Barbados in 1999 to that in 2000?
Provide a short and direct response. 0.9. What is the ratio of the Expenditure(as % of GDP) in Ethiopia in 1999 to that in 2000?
Offer a very short reply. 0.68. What is the ratio of the Expenditure(as % of GDP) in Turkey in 1999 to that in 2000?
Provide a succinct answer. 1.06. What is the ratio of the Expenditure(as % of GDP) of World in 1999 to that in 2001?
Give a very brief answer. 0.89. What is the ratio of the Expenditure(as % of GDP) in Barbados in 1999 to that in 2001?
Offer a terse response. 0.78. What is the ratio of the Expenditure(as % of GDP) of Ethiopia in 1999 to that in 2001?
Offer a terse response. 1.97. What is the ratio of the Expenditure(as % of GDP) in Turkey in 1999 to that in 2001?
Offer a very short reply. 1.28. What is the ratio of the Expenditure(as % of GDP) in World in 1999 to that in 2002?
Keep it short and to the point. 0.81. What is the ratio of the Expenditure(as % of GDP) in Barbados in 1999 to that in 2002?
Your response must be concise. 0.84. What is the ratio of the Expenditure(as % of GDP) in Ethiopia in 1999 to that in 2002?
Your answer should be compact. 1.04. What is the ratio of the Expenditure(as % of GDP) of Turkey in 1999 to that in 2002?
Give a very brief answer. 2.18. What is the ratio of the Expenditure(as % of GDP) in World in 1999 to that in 2003?
Provide a short and direct response. 0.75. What is the ratio of the Expenditure(as % of GDP) in Barbados in 1999 to that in 2003?
Offer a terse response. 0.83. What is the ratio of the Expenditure(as % of GDP) in Ethiopia in 1999 to that in 2003?
Keep it short and to the point. 0.81. What is the ratio of the Expenditure(as % of GDP) in Turkey in 1999 to that in 2003?
Your answer should be compact. 7.54. What is the ratio of the Expenditure(as % of GDP) of World in 2000 to that in 2001?
Offer a very short reply. 0.9. What is the ratio of the Expenditure(as % of GDP) in Barbados in 2000 to that in 2001?
Provide a succinct answer. 0.88. What is the ratio of the Expenditure(as % of GDP) of Ethiopia in 2000 to that in 2001?
Keep it short and to the point. 2.9. What is the ratio of the Expenditure(as % of GDP) in Turkey in 2000 to that in 2001?
Ensure brevity in your answer.  1.2. What is the ratio of the Expenditure(as % of GDP) of World in 2000 to that in 2002?
Provide a short and direct response. 0.82. What is the ratio of the Expenditure(as % of GDP) in Barbados in 2000 to that in 2002?
Your response must be concise. 0.93. What is the ratio of the Expenditure(as % of GDP) in Ethiopia in 2000 to that in 2002?
Ensure brevity in your answer.  1.53. What is the ratio of the Expenditure(as % of GDP) in Turkey in 2000 to that in 2002?
Provide a succinct answer. 2.05. What is the ratio of the Expenditure(as % of GDP) of World in 2000 to that in 2003?
Your response must be concise. 0.76. What is the ratio of the Expenditure(as % of GDP) of Barbados in 2000 to that in 2003?
Your answer should be compact. 0.92. What is the ratio of the Expenditure(as % of GDP) of Ethiopia in 2000 to that in 2003?
Your answer should be compact. 1.2. What is the ratio of the Expenditure(as % of GDP) of Turkey in 2000 to that in 2003?
Your response must be concise. 7.11. What is the ratio of the Expenditure(as % of GDP) in World in 2001 to that in 2002?
Provide a short and direct response. 0.91. What is the ratio of the Expenditure(as % of GDP) of Barbados in 2001 to that in 2002?
Make the answer very short. 1.07. What is the ratio of the Expenditure(as % of GDP) in Ethiopia in 2001 to that in 2002?
Keep it short and to the point. 0.53. What is the ratio of the Expenditure(as % of GDP) of Turkey in 2001 to that in 2002?
Offer a terse response. 1.71. What is the ratio of the Expenditure(as % of GDP) of World in 2001 to that in 2003?
Keep it short and to the point. 0.85. What is the ratio of the Expenditure(as % of GDP) in Barbados in 2001 to that in 2003?
Offer a very short reply. 1.06. What is the ratio of the Expenditure(as % of GDP) in Ethiopia in 2001 to that in 2003?
Offer a very short reply. 0.41. What is the ratio of the Expenditure(as % of GDP) in Turkey in 2001 to that in 2003?
Provide a succinct answer. 5.91. What is the ratio of the Expenditure(as % of GDP) of World in 2002 to that in 2003?
Provide a short and direct response. 0.93. What is the ratio of the Expenditure(as % of GDP) of Barbados in 2002 to that in 2003?
Give a very brief answer. 0.99. What is the ratio of the Expenditure(as % of GDP) in Ethiopia in 2002 to that in 2003?
Your answer should be compact. 0.78. What is the ratio of the Expenditure(as % of GDP) of Turkey in 2002 to that in 2003?
Ensure brevity in your answer.  3.46. What is the difference between the highest and the second highest Expenditure(as % of GDP) of World?
Make the answer very short. 0.04. What is the difference between the highest and the second highest Expenditure(as % of GDP) of Barbados?
Keep it short and to the point. 0.23. What is the difference between the highest and the second highest Expenditure(as % of GDP) of Ethiopia?
Make the answer very short. 0.11. What is the difference between the highest and the second highest Expenditure(as % of GDP) of Turkey?
Make the answer very short. 0.17. What is the difference between the highest and the lowest Expenditure(as % of GDP) in World?
Your answer should be compact. 0.15. What is the difference between the highest and the lowest Expenditure(as % of GDP) of Barbados?
Provide a succinct answer. 1.17. What is the difference between the highest and the lowest Expenditure(as % of GDP) of Ethiopia?
Provide a succinct answer. 0.42. What is the difference between the highest and the lowest Expenditure(as % of GDP) of Turkey?
Your answer should be compact. 1.75. 